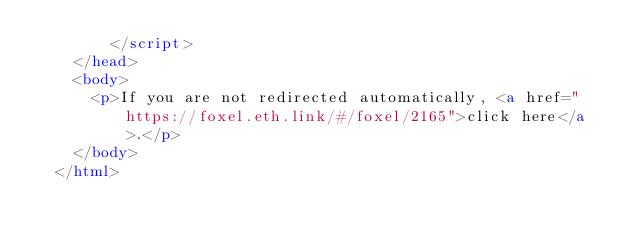Convert code to text. <code><loc_0><loc_0><loc_500><loc_500><_HTML_>        </script>
    </head>
    <body>
      <p>If you are not redirected automatically, <a href="https://foxel.eth.link/#/foxel/2165">click here</a>.</p>
    </body>
  </html></code> 